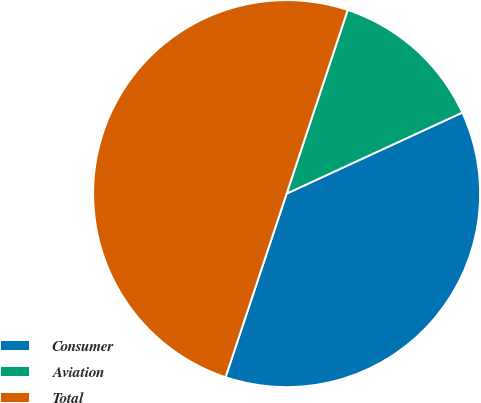Convert chart. <chart><loc_0><loc_0><loc_500><loc_500><pie_chart><fcel>Consumer<fcel>Aviation<fcel>Total<nl><fcel>36.99%<fcel>13.01%<fcel>50.0%<nl></chart> 